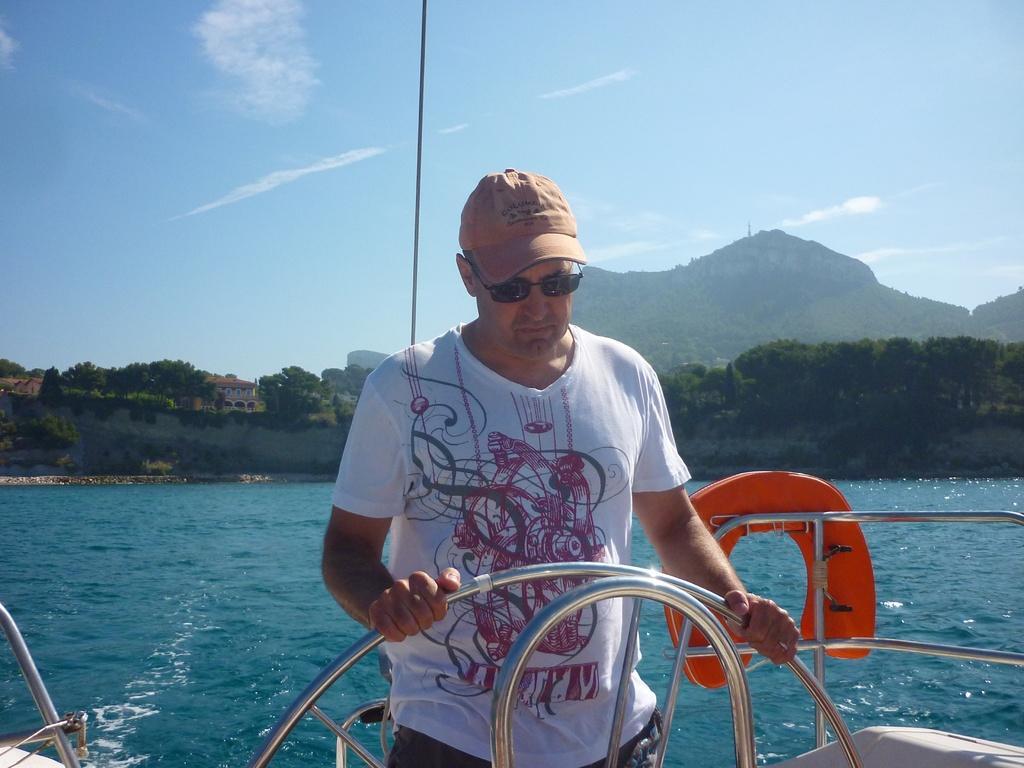Describe this image in one or two sentences. In this image we can see a person wearing cap and goggles. There are handles. Also there is a tube. In the back there is water. In the background we can see hills, trees and sky with clouds. Also there is a building. 